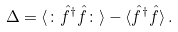<formula> <loc_0><loc_0><loc_500><loc_500>\Delta = \langle \colon \hat { f } ^ { \dagger } \hat { f } \colon \rangle - \langle \hat { f } ^ { \dagger } \hat { f } \rangle \, .</formula> 